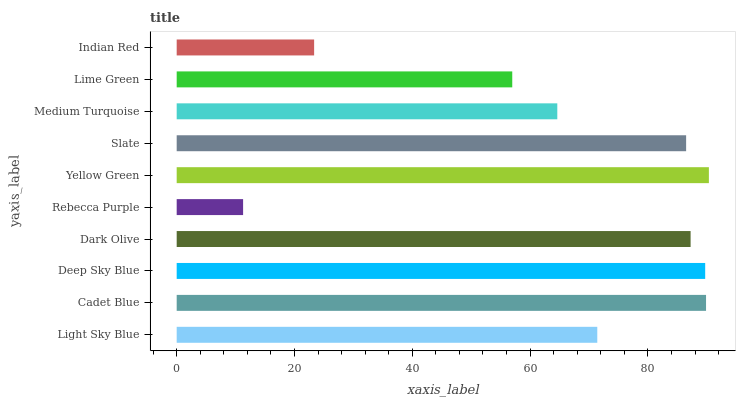Is Rebecca Purple the minimum?
Answer yes or no. Yes. Is Yellow Green the maximum?
Answer yes or no. Yes. Is Cadet Blue the minimum?
Answer yes or no. No. Is Cadet Blue the maximum?
Answer yes or no. No. Is Cadet Blue greater than Light Sky Blue?
Answer yes or no. Yes. Is Light Sky Blue less than Cadet Blue?
Answer yes or no. Yes. Is Light Sky Blue greater than Cadet Blue?
Answer yes or no. No. Is Cadet Blue less than Light Sky Blue?
Answer yes or no. No. Is Slate the high median?
Answer yes or no. Yes. Is Light Sky Blue the low median?
Answer yes or no. Yes. Is Deep Sky Blue the high median?
Answer yes or no. No. Is Lime Green the low median?
Answer yes or no. No. 